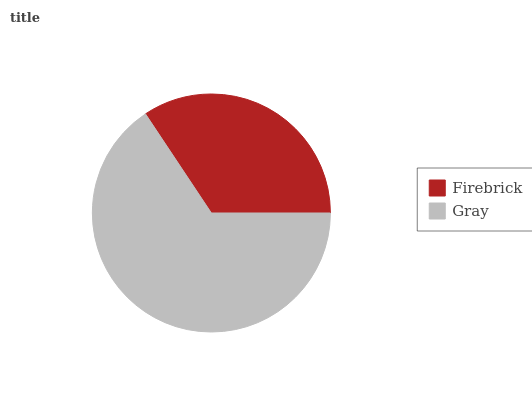Is Firebrick the minimum?
Answer yes or no. Yes. Is Gray the maximum?
Answer yes or no. Yes. Is Gray the minimum?
Answer yes or no. No. Is Gray greater than Firebrick?
Answer yes or no. Yes. Is Firebrick less than Gray?
Answer yes or no. Yes. Is Firebrick greater than Gray?
Answer yes or no. No. Is Gray less than Firebrick?
Answer yes or no. No. Is Gray the high median?
Answer yes or no. Yes. Is Firebrick the low median?
Answer yes or no. Yes. Is Firebrick the high median?
Answer yes or no. No. Is Gray the low median?
Answer yes or no. No. 